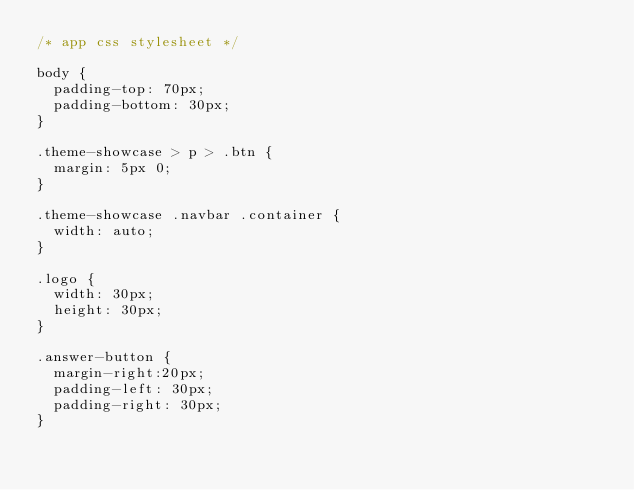Convert code to text. <code><loc_0><loc_0><loc_500><loc_500><_CSS_>/* app css stylesheet */

body {
  padding-top: 70px;
  padding-bottom: 30px;
}

.theme-showcase > p > .btn {
  margin: 5px 0;
}

.theme-showcase .navbar .container {
  width: auto;
}

.logo {
  width: 30px;
  height: 30px;
}

.answer-button {
  margin-right:20px;
  padding-left: 30px;
  padding-right: 30px;
}
</code> 